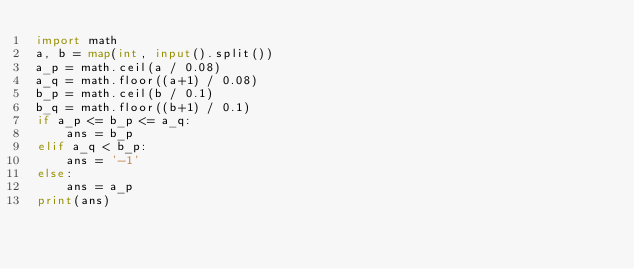<code> <loc_0><loc_0><loc_500><loc_500><_Python_>import math
a, b = map(int, input().split())
a_p = math.ceil(a / 0.08)
a_q = math.floor((a+1) / 0.08)
b_p = math.ceil(b / 0.1)
b_q = math.floor((b+1) / 0.1)
if a_p <= b_p <= a_q:
    ans = b_p
elif a_q < b_p:
    ans = '-1'
else:
    ans = a_p
print(ans)</code> 